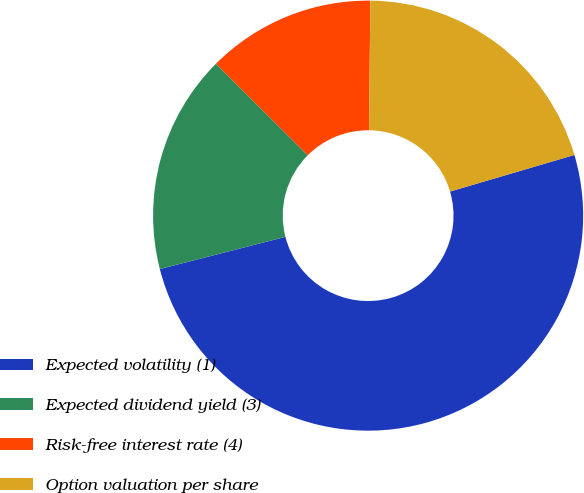Convert chart to OTSL. <chart><loc_0><loc_0><loc_500><loc_500><pie_chart><fcel>Expected volatility (1)<fcel>Expected dividend yield (3)<fcel>Risk-free interest rate (4)<fcel>Option valuation per share<nl><fcel>50.56%<fcel>16.48%<fcel>12.68%<fcel>20.28%<nl></chart> 